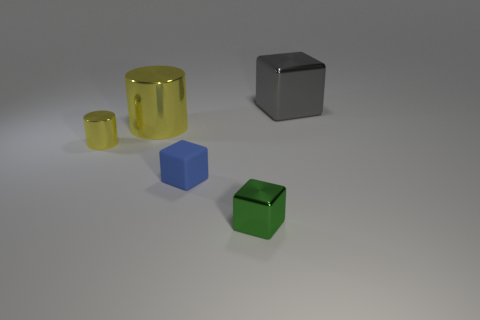What can the reflective surface of the gray block tell us about the environment? The reflective surface of the gray block shows diffused reflections due to the soft lighting in the environment. It indicates that the surroundings might contain a few light sources and that the ambient light is evenly spread out, likely within an indoor setting with neutral-colored walls. 